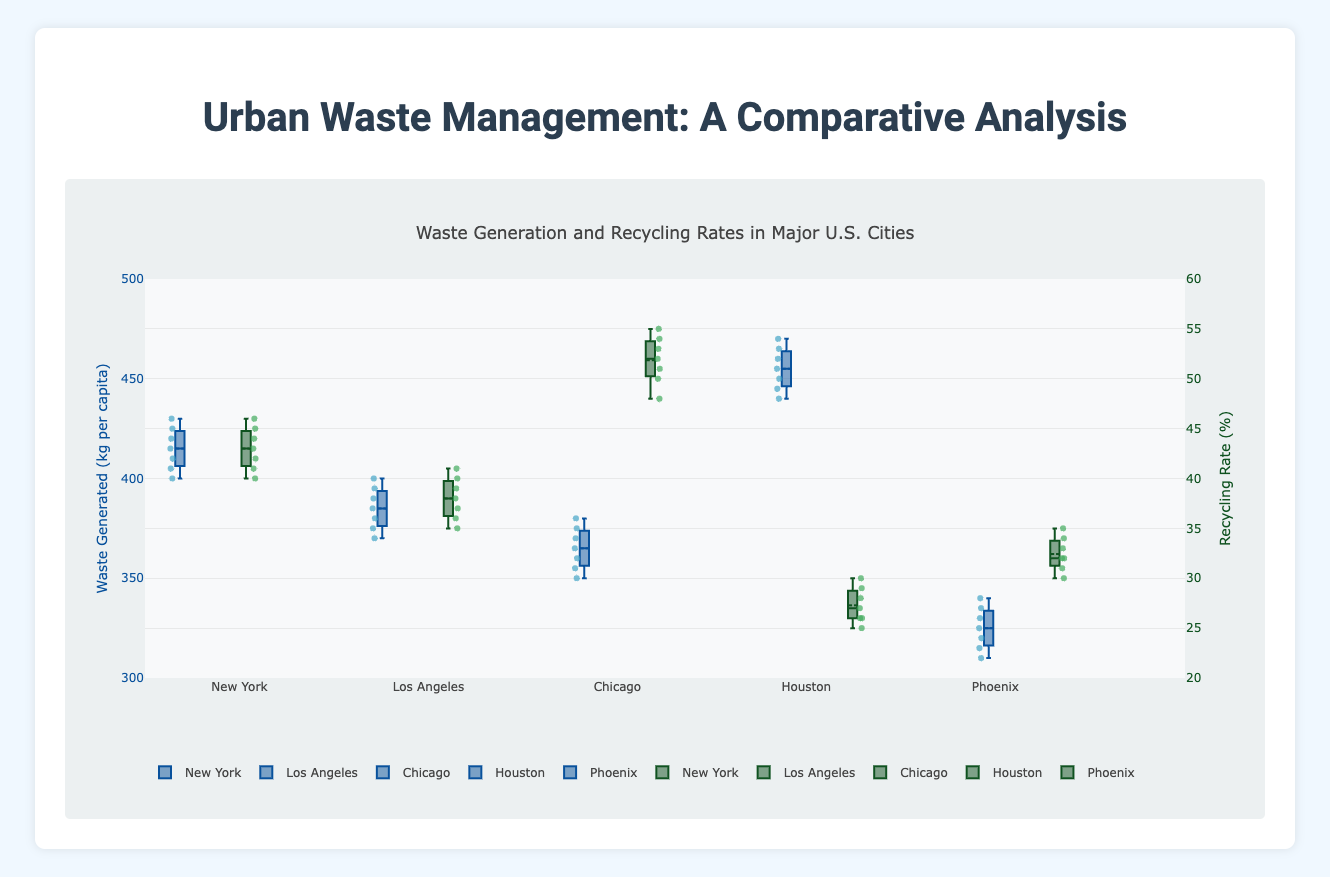What are the ranges of waste generated per capita in New York? The range of a box plot is indicated by the whiskers, which represent the minimum and maximum values. For New York, these are the lowest and highest points on the box plot with values around 400 and 430 kg per capita.
Answer: 400-430 kg Which city has the highest median waste generation per capita? To find the median, look for the horizontal line inside each box. The box plot for Houston has the highest median compared to the other cities.
Answer: Houston What is the median recycling rate in Chicago? The median is shown by the horizontal line within the box. For Chicago, it's at approximately 52%.
Answer: 52% How do the interquartile ranges of recycling rates compare between Phoenix and Los Angeles? The interquartile range is the box itself (the middle 50% of the data). Phoenix has a smaller interquartile range than Los Angeles, indicating less variability in recycling rates.
Answer: Phoenix has a smaller IQR Which city shows the least variability in waste generation per capita? Variability can be assessed by the spread of the box plot; the smaller the box and whiskers, the less variability. Chicago shows the least variability in waste generation.
Answer: Chicago What are the maximum values for recycling rates observed in all cities? The maximum value is indicated by the highest point (top whisker) in each city's box plot for recycling rates. These are Houston (30%), New York (46%), Los Angeles (41%), Chicago (55%), and Phoenix (35%).
Answer: New York 46%, Los Angeles 41%, Chicago 55%, Houston 30%, Phoenix 35% For which city are the waste generation per capita values closest to its mean? The box plot also shows a mean line. For Phoenix, the values are closely clustered around its mean, indicating consistency.
Answer: Phoenix How do the mean recycling rates compare between New York and Houston? The mean is shown by a small line or point within the box. New York’s mean recycling rate is significantly higher than Houston’s mean recycling rate.
Answer: New York is higher For which city does the median value of waste generation fall below the overall range? Only cities with a wide range where the median falls noticeably below the top of the box would apply. Phoenix, for instance, has its median well within the overall range.
Answer: None Which cities have overlapping interquartile ranges for recycling rates? Cities with overlapping boxes indicate similar interquartile ranges. Los Angeles and Phoenix have overlapping interquartile ranges for recycling rates.
Answer: Los Angeles and Phoenix 